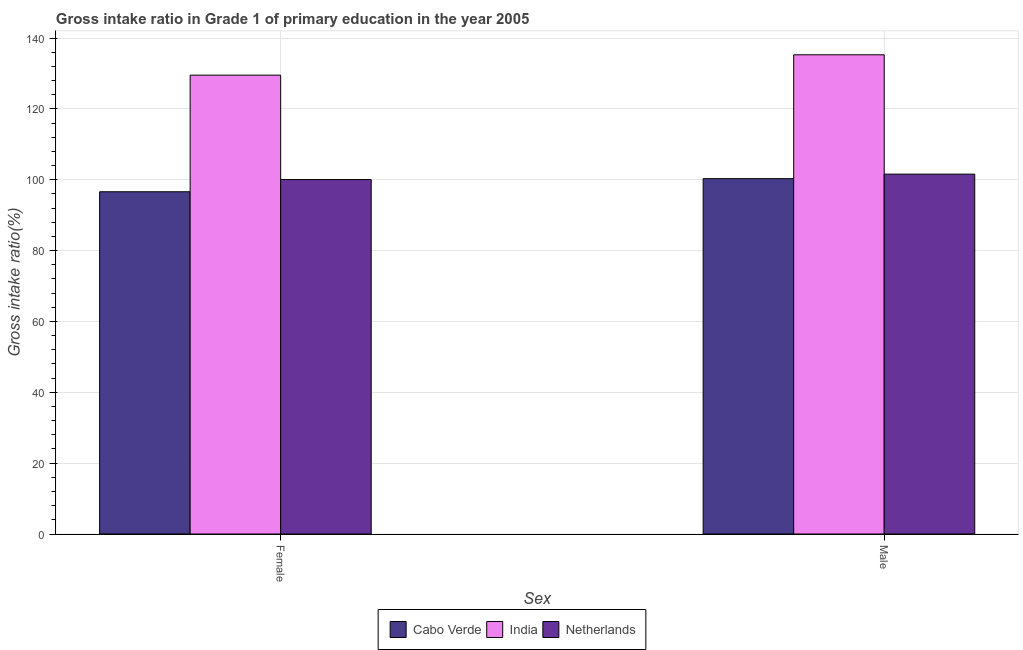Are the number of bars per tick equal to the number of legend labels?
Offer a terse response. Yes. What is the label of the 2nd group of bars from the left?
Keep it short and to the point. Male. What is the gross intake ratio(female) in India?
Give a very brief answer. 129.52. Across all countries, what is the maximum gross intake ratio(male)?
Your answer should be very brief. 135.27. Across all countries, what is the minimum gross intake ratio(female)?
Keep it short and to the point. 96.61. In which country was the gross intake ratio(female) maximum?
Make the answer very short. India. In which country was the gross intake ratio(female) minimum?
Make the answer very short. Cabo Verde. What is the total gross intake ratio(female) in the graph?
Your response must be concise. 326.18. What is the difference between the gross intake ratio(female) in Netherlands and that in Cabo Verde?
Keep it short and to the point. 3.45. What is the difference between the gross intake ratio(female) in Netherlands and the gross intake ratio(male) in Cabo Verde?
Your answer should be compact. -0.25. What is the average gross intake ratio(female) per country?
Give a very brief answer. 108.73. What is the difference between the gross intake ratio(male) and gross intake ratio(female) in Netherlands?
Make the answer very short. 1.53. In how many countries, is the gross intake ratio(female) greater than 96 %?
Ensure brevity in your answer.  3. What is the ratio of the gross intake ratio(male) in Cabo Verde to that in India?
Keep it short and to the point. 0.74. In how many countries, is the gross intake ratio(female) greater than the average gross intake ratio(female) taken over all countries?
Give a very brief answer. 1. What does the 1st bar from the left in Male represents?
Keep it short and to the point. Cabo Verde. What does the 3rd bar from the right in Female represents?
Give a very brief answer. Cabo Verde. How many bars are there?
Your answer should be very brief. 6. Are all the bars in the graph horizontal?
Offer a terse response. No. What is the difference between two consecutive major ticks on the Y-axis?
Provide a succinct answer. 20. Does the graph contain any zero values?
Your answer should be compact. No. Does the graph contain grids?
Your response must be concise. Yes. Where does the legend appear in the graph?
Your answer should be very brief. Bottom center. How many legend labels are there?
Offer a terse response. 3. What is the title of the graph?
Your response must be concise. Gross intake ratio in Grade 1 of primary education in the year 2005. Does "Norway" appear as one of the legend labels in the graph?
Provide a succinct answer. No. What is the label or title of the X-axis?
Provide a succinct answer. Sex. What is the label or title of the Y-axis?
Make the answer very short. Gross intake ratio(%). What is the Gross intake ratio(%) in Cabo Verde in Female?
Keep it short and to the point. 96.61. What is the Gross intake ratio(%) in India in Female?
Provide a succinct answer. 129.52. What is the Gross intake ratio(%) in Netherlands in Female?
Give a very brief answer. 100.05. What is the Gross intake ratio(%) in Cabo Verde in Male?
Ensure brevity in your answer.  100.3. What is the Gross intake ratio(%) in India in Male?
Your answer should be very brief. 135.27. What is the Gross intake ratio(%) in Netherlands in Male?
Offer a very short reply. 101.58. Across all Sex, what is the maximum Gross intake ratio(%) in Cabo Verde?
Keep it short and to the point. 100.3. Across all Sex, what is the maximum Gross intake ratio(%) in India?
Keep it short and to the point. 135.27. Across all Sex, what is the maximum Gross intake ratio(%) of Netherlands?
Provide a short and direct response. 101.58. Across all Sex, what is the minimum Gross intake ratio(%) in Cabo Verde?
Offer a very short reply. 96.61. Across all Sex, what is the minimum Gross intake ratio(%) of India?
Ensure brevity in your answer.  129.52. Across all Sex, what is the minimum Gross intake ratio(%) of Netherlands?
Provide a succinct answer. 100.05. What is the total Gross intake ratio(%) in Cabo Verde in the graph?
Give a very brief answer. 196.9. What is the total Gross intake ratio(%) in India in the graph?
Your answer should be compact. 264.78. What is the total Gross intake ratio(%) in Netherlands in the graph?
Provide a succinct answer. 201.63. What is the difference between the Gross intake ratio(%) in Cabo Verde in Female and that in Male?
Make the answer very short. -3.69. What is the difference between the Gross intake ratio(%) in India in Female and that in Male?
Your answer should be compact. -5.75. What is the difference between the Gross intake ratio(%) of Netherlands in Female and that in Male?
Ensure brevity in your answer.  -1.53. What is the difference between the Gross intake ratio(%) in Cabo Verde in Female and the Gross intake ratio(%) in India in Male?
Make the answer very short. -38.66. What is the difference between the Gross intake ratio(%) in Cabo Verde in Female and the Gross intake ratio(%) in Netherlands in Male?
Keep it short and to the point. -4.98. What is the difference between the Gross intake ratio(%) of India in Female and the Gross intake ratio(%) of Netherlands in Male?
Keep it short and to the point. 27.94. What is the average Gross intake ratio(%) of Cabo Verde per Sex?
Offer a very short reply. 98.45. What is the average Gross intake ratio(%) of India per Sex?
Ensure brevity in your answer.  132.39. What is the average Gross intake ratio(%) of Netherlands per Sex?
Provide a succinct answer. 100.82. What is the difference between the Gross intake ratio(%) in Cabo Verde and Gross intake ratio(%) in India in Female?
Give a very brief answer. -32.91. What is the difference between the Gross intake ratio(%) in Cabo Verde and Gross intake ratio(%) in Netherlands in Female?
Offer a very short reply. -3.45. What is the difference between the Gross intake ratio(%) in India and Gross intake ratio(%) in Netherlands in Female?
Your answer should be compact. 29.46. What is the difference between the Gross intake ratio(%) in Cabo Verde and Gross intake ratio(%) in India in Male?
Give a very brief answer. -34.97. What is the difference between the Gross intake ratio(%) in Cabo Verde and Gross intake ratio(%) in Netherlands in Male?
Offer a very short reply. -1.28. What is the difference between the Gross intake ratio(%) of India and Gross intake ratio(%) of Netherlands in Male?
Your answer should be compact. 33.69. What is the ratio of the Gross intake ratio(%) in Cabo Verde in Female to that in Male?
Provide a short and direct response. 0.96. What is the ratio of the Gross intake ratio(%) in India in Female to that in Male?
Your response must be concise. 0.96. What is the ratio of the Gross intake ratio(%) of Netherlands in Female to that in Male?
Offer a terse response. 0.98. What is the difference between the highest and the second highest Gross intake ratio(%) of Cabo Verde?
Your response must be concise. 3.69. What is the difference between the highest and the second highest Gross intake ratio(%) in India?
Give a very brief answer. 5.75. What is the difference between the highest and the second highest Gross intake ratio(%) in Netherlands?
Make the answer very short. 1.53. What is the difference between the highest and the lowest Gross intake ratio(%) of Cabo Verde?
Your answer should be compact. 3.69. What is the difference between the highest and the lowest Gross intake ratio(%) of India?
Give a very brief answer. 5.75. What is the difference between the highest and the lowest Gross intake ratio(%) in Netherlands?
Keep it short and to the point. 1.53. 